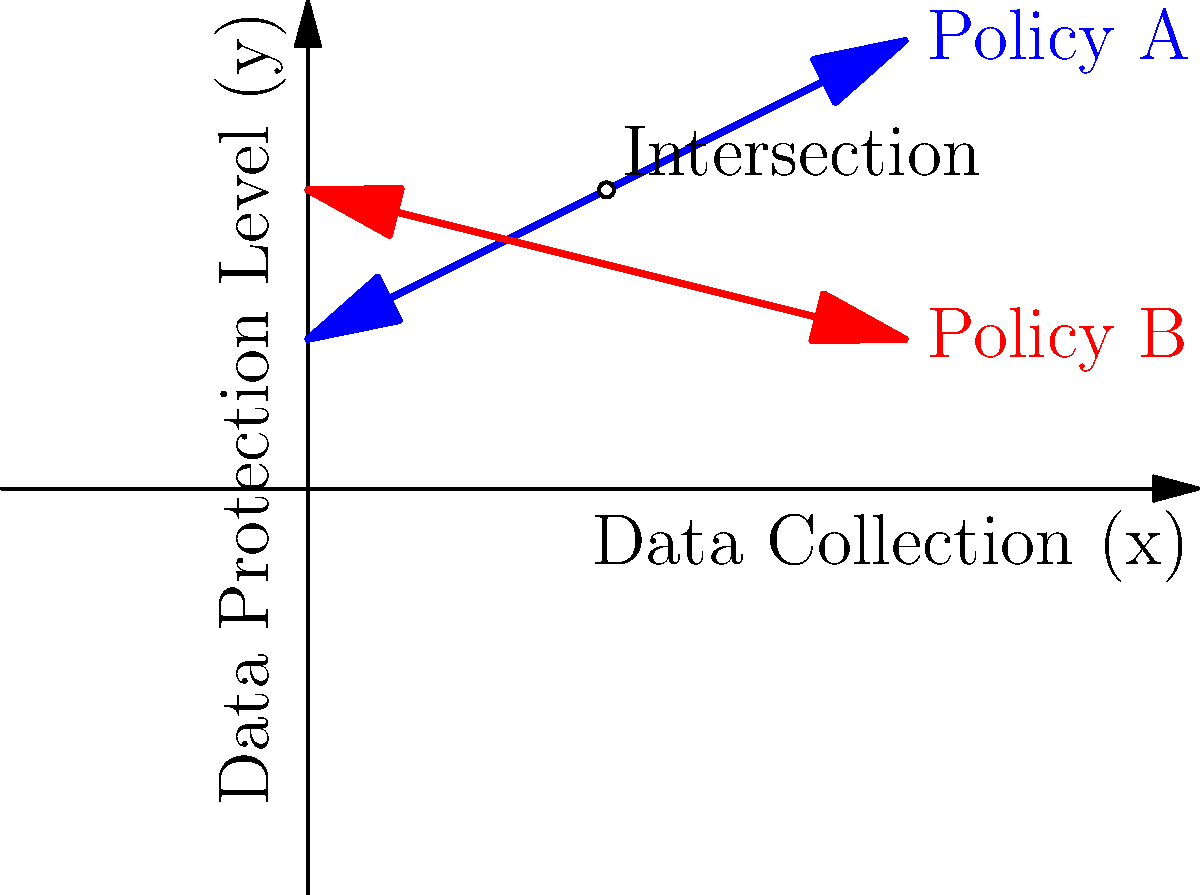In the graph, two lines represent different data protection policies. Policy A is represented by the equation $y = 0.5x + 2$, while Policy B is represented by $y = -0.25x + 4$. At what level of data collection (x-coordinate) do these policies intersect, potentially creating a compromise in data protection standards? To find the intersection point of the two policy lines, we need to solve the system of equations:

1) Policy A: $y = 0.5x + 2$
2) Policy B: $y = -0.25x + 4$

At the intersection point, the y-values are equal, so we can set the right sides of the equations equal to each other:

3) $0.5x + 2 = -0.25x + 4$

Now, let's solve for x:

4) $0.5x + 0.25x = 4 - 2$
5) $0.75x = 2$
6) $x = 2 / 0.75 = 8/3 \approx 2.67$

Therefore, the policies intersect when the level of data collection (x-coordinate) is $8/3$ or approximately 2.67.

To verify, we can substitute this x-value into either of the original equations to find the y-coordinate:

7) $y = 0.5(8/3) + 2 = 4/3 + 2 = 10/3 = 3.33$

So, the intersection point is $(8/3, 10/3)$ or approximately (2.67, 3.33).
Answer: $x = 8/3$ 